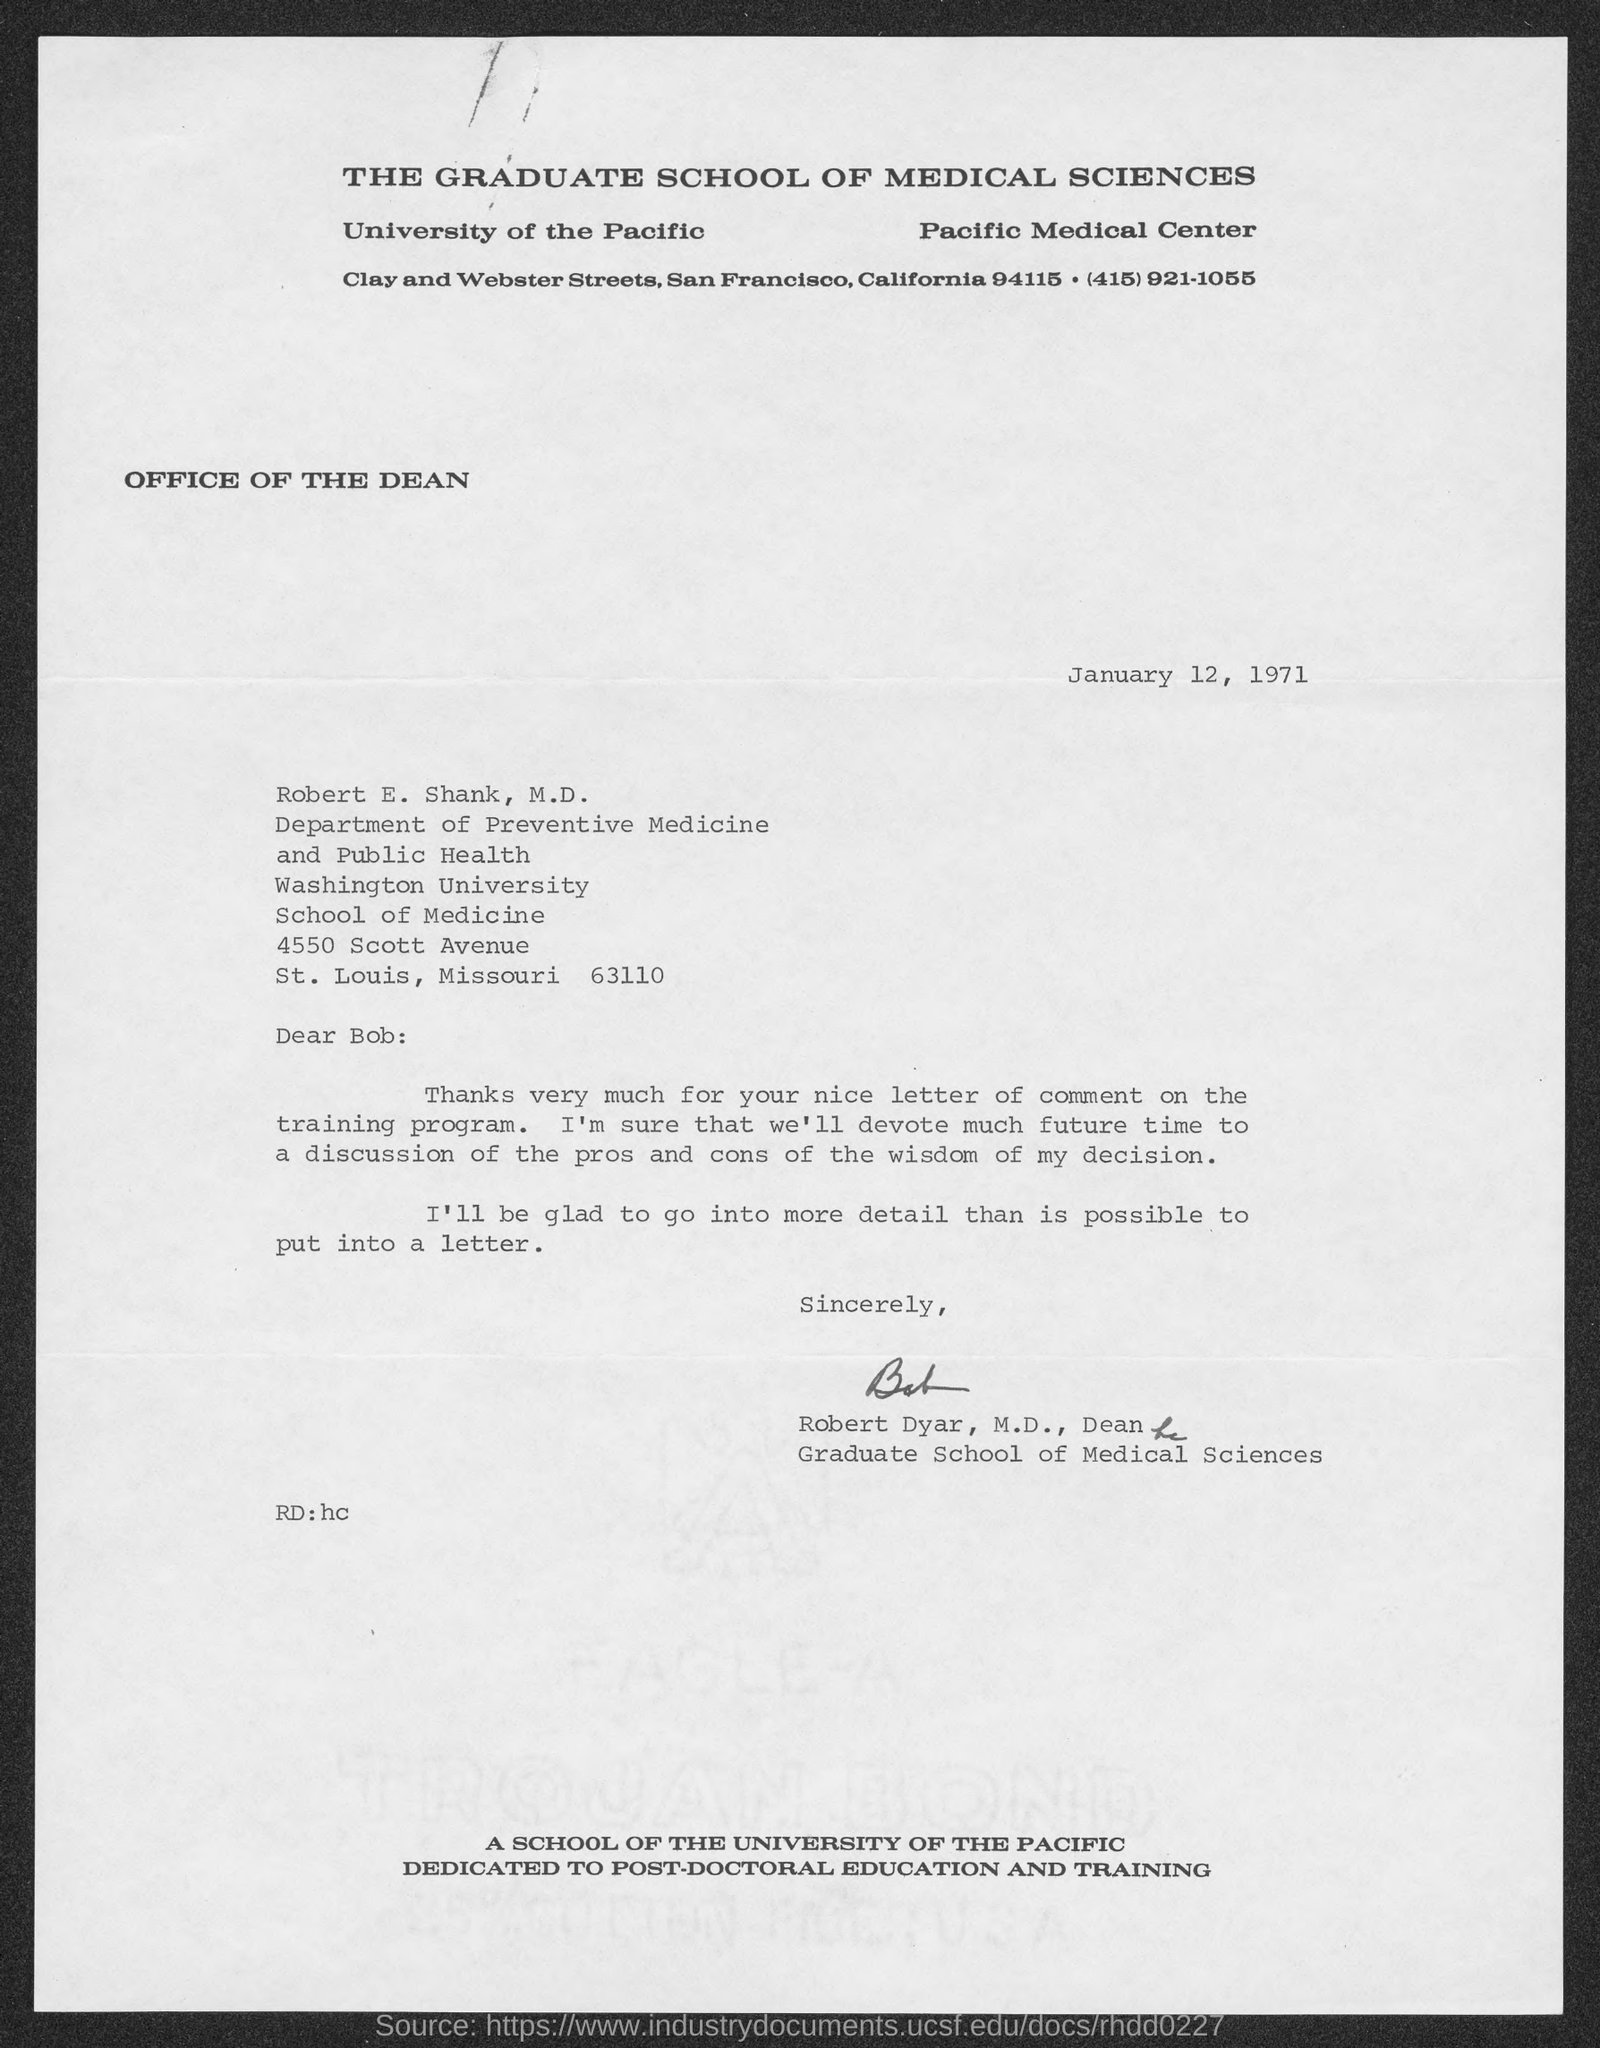Give some essential details in this illustration. The date of the letter is January 12, 1971. 